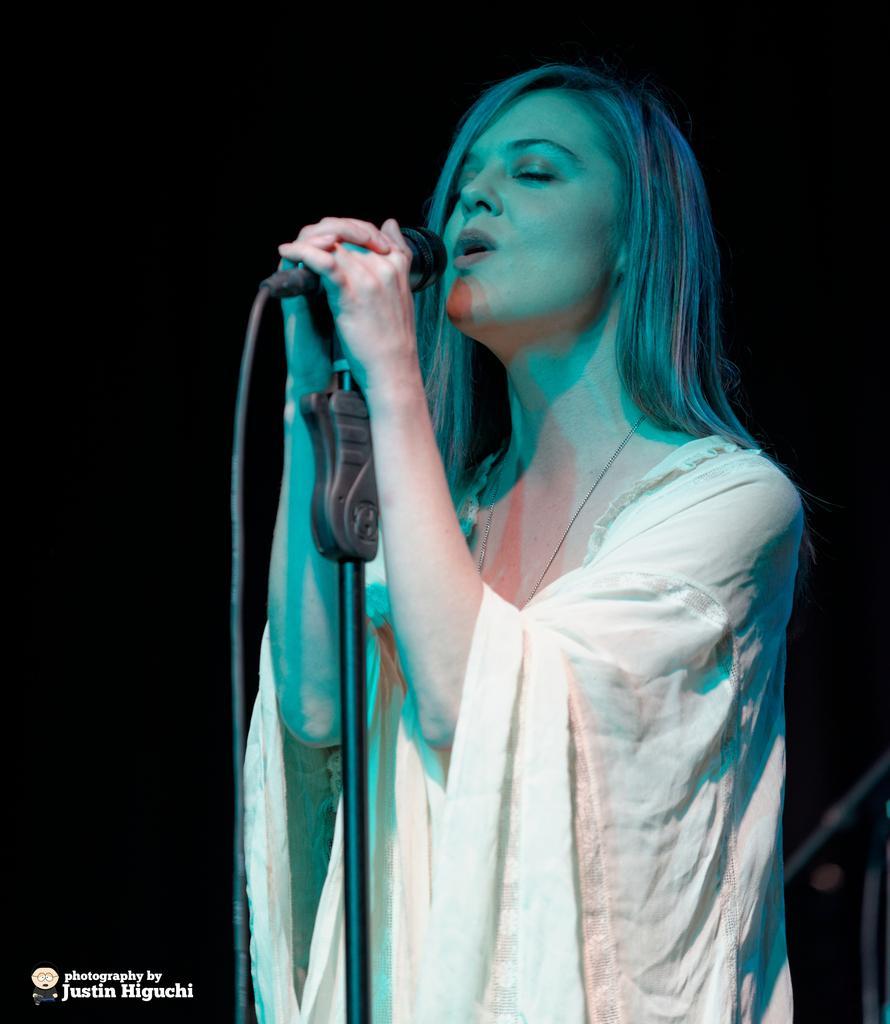Please provide a concise description of this image. In this image In the middle there is a woman she is singing she hold a mic her hair is short she wear white dress. 